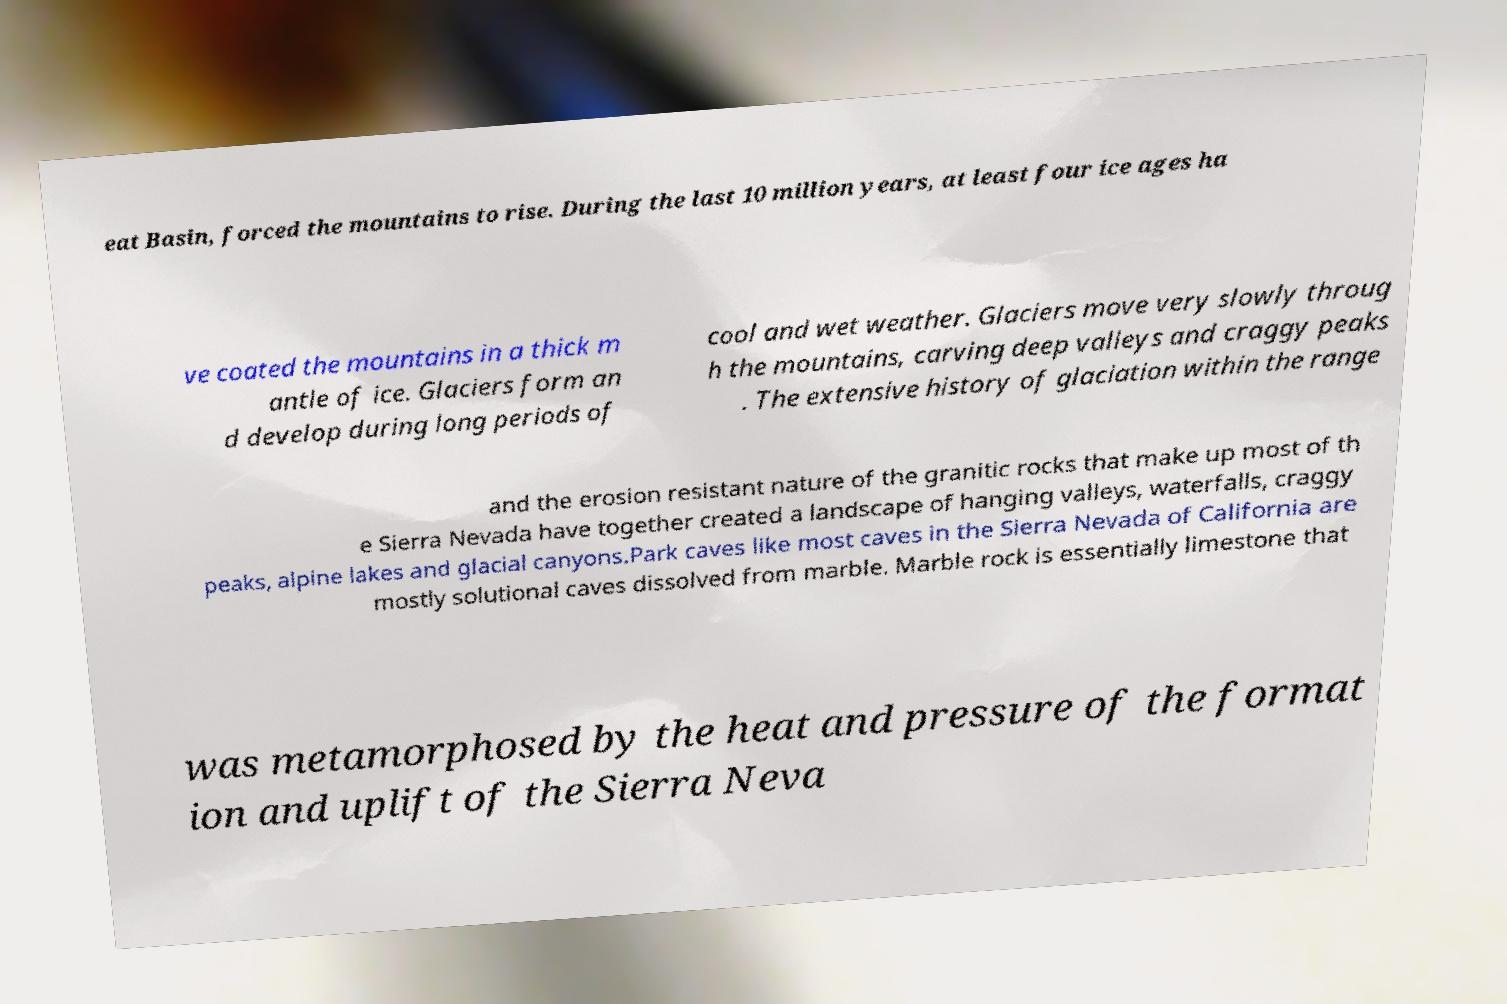Can you read and provide the text displayed in the image?This photo seems to have some interesting text. Can you extract and type it out for me? eat Basin, forced the mountains to rise. During the last 10 million years, at least four ice ages ha ve coated the mountains in a thick m antle of ice. Glaciers form an d develop during long periods of cool and wet weather. Glaciers move very slowly throug h the mountains, carving deep valleys and craggy peaks . The extensive history of glaciation within the range and the erosion resistant nature of the granitic rocks that make up most of th e Sierra Nevada have together created a landscape of hanging valleys, waterfalls, craggy peaks, alpine lakes and glacial canyons.Park caves like most caves in the Sierra Nevada of California are mostly solutional caves dissolved from marble. Marble rock is essentially limestone that was metamorphosed by the heat and pressure of the format ion and uplift of the Sierra Neva 